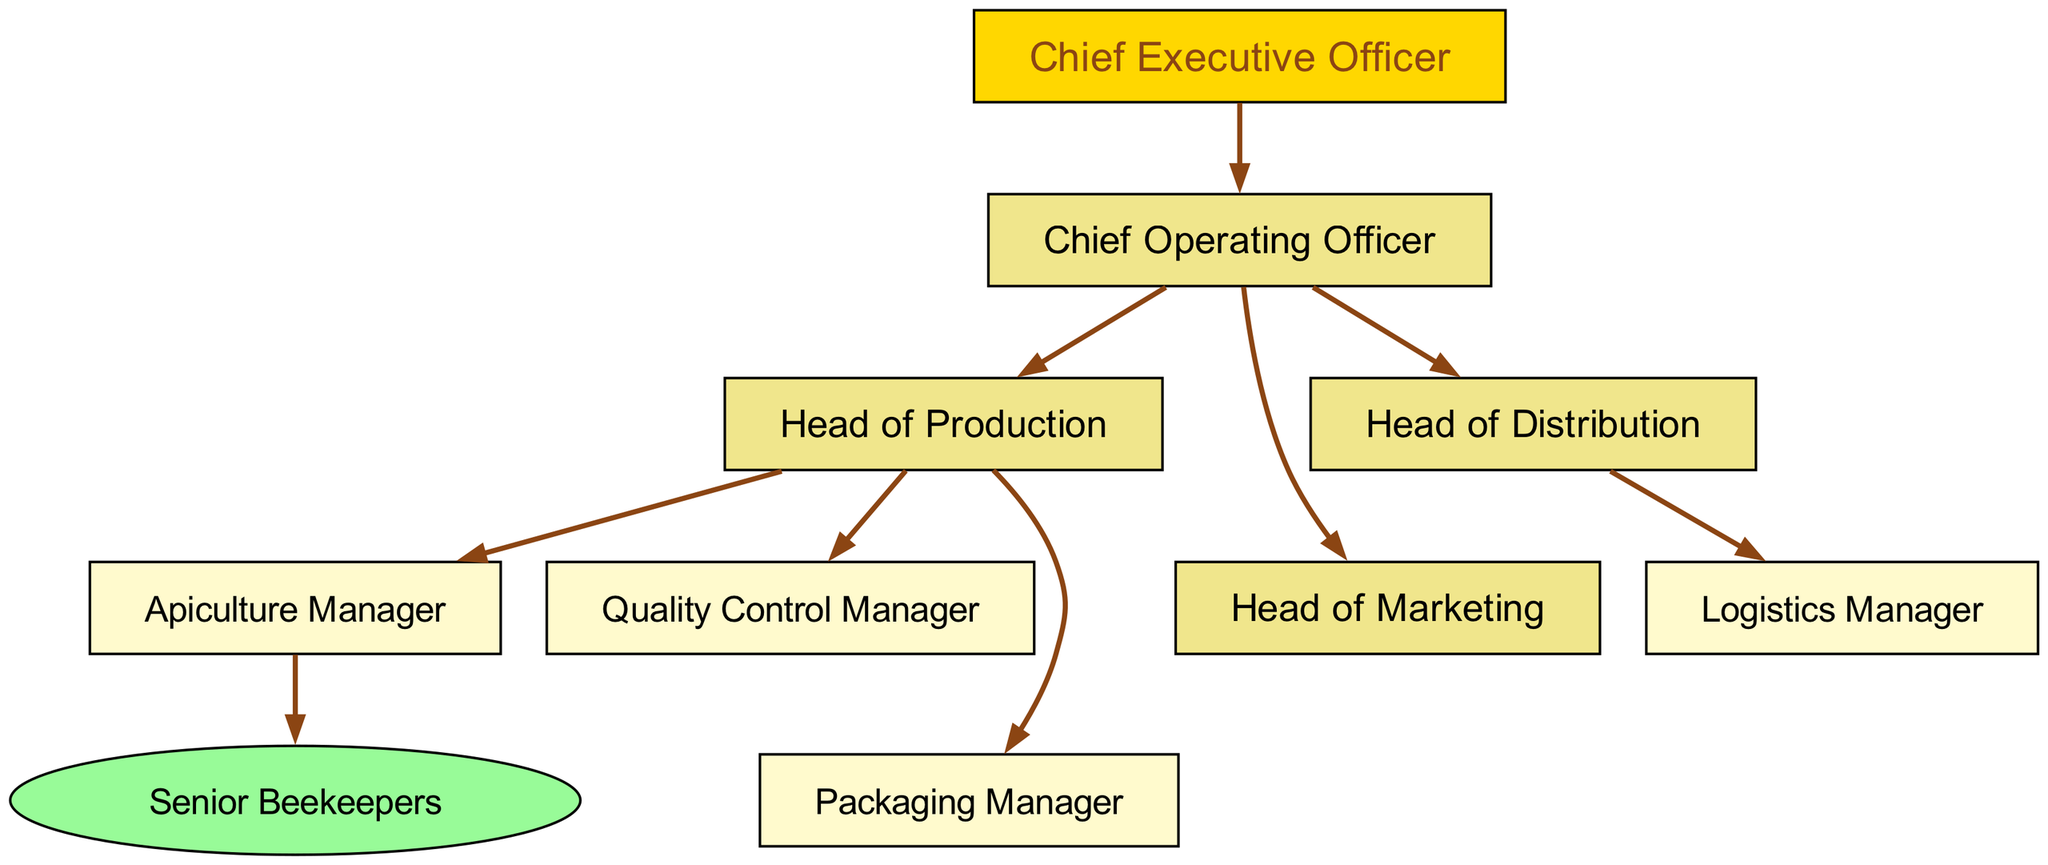What is the role directly under the CEO? The organizational chart shows that the role immediately below the CEO is the Chief Operating Officer (COO). This is indicated by the directed edge leading from the CEO to the COO.
Answer: Chief Operating Officer How many heads report to the COO? By examining the diagram, we see three roles—Production Head, Distribution Head, and Marketing Head—that branch out from the COO. Thus, the total number of heads reporting to the COO is three.
Answer: Three Who manages beekeepers? The Apiculture Manager is depicted as managing the Senior Beekeepers in the diagram. A direct edge connects the Apiculture Manager to the Beekeepers, indicating management responsibilities.
Answer: Apiculture Manager What position oversees logistics? The Logistics Manager is the position responsible for overseeing logistics within the organization. This can be derived from the direct connection from the Distribution Head to the Logistics Manager.
Answer: Logistics Manager Which role is responsible for quality control in production? The role that oversees quality control within production is the Quality Control Manager. This is evident from the directed edge that connects the Production Head to the Quality Control Manager.
Answer: Quality Control Manager How many positions are under the Production Head? The Production Head oversees three roles: Apiculture Manager, Quality Control Manager, and Packaging Manager. By counting the directed edges from the Production Head, we confirm this number.
Answer: Three What is the highest position in the organization? The highest position in the company structure, as represented in the diagram, is the Chief Executive Officer (CEO). This is the top node without any edges leading into it.
Answer: Chief Executive Officer What color represents the COO and heads? In the diagram, the Chief Operating Officer and the heads of departments (Production Head, Distribution Head, and Marketing Head) are represented in a light yellow color (#F0E68C). This color coding applies to these roles specifically.
Answer: Light yellow What role comes after Distribution Head? The role that comes immediately after the Distribution Head is the Logistics Manager, as shown by the directed relationship from the Distribution Head to the Logistics Manager in the organizational chart.
Answer: Logistics Manager 